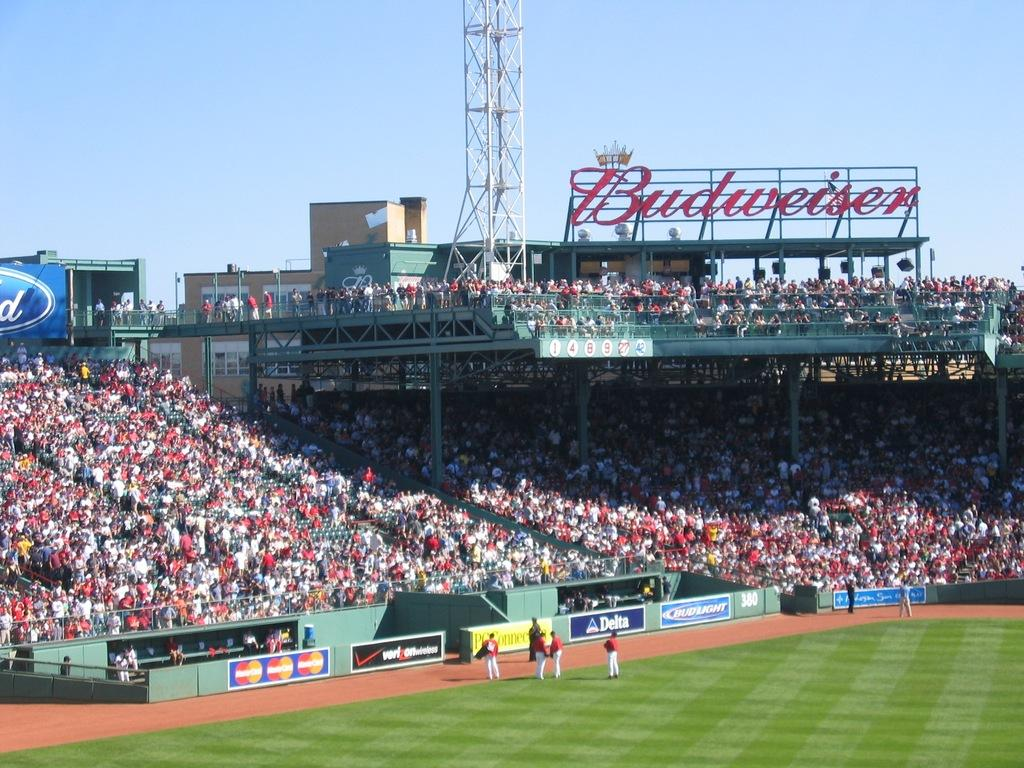<image>
Provide a brief description of the given image. A huge Budweiser sign rises over this baseball field. 